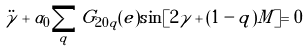<formula> <loc_0><loc_0><loc_500><loc_500>\ddot { \gamma } + \alpha _ { 0 } \sum _ { q } G _ { 2 0 q } ( e ) \sin [ 2 \gamma + ( 1 - q ) M ] = 0</formula> 